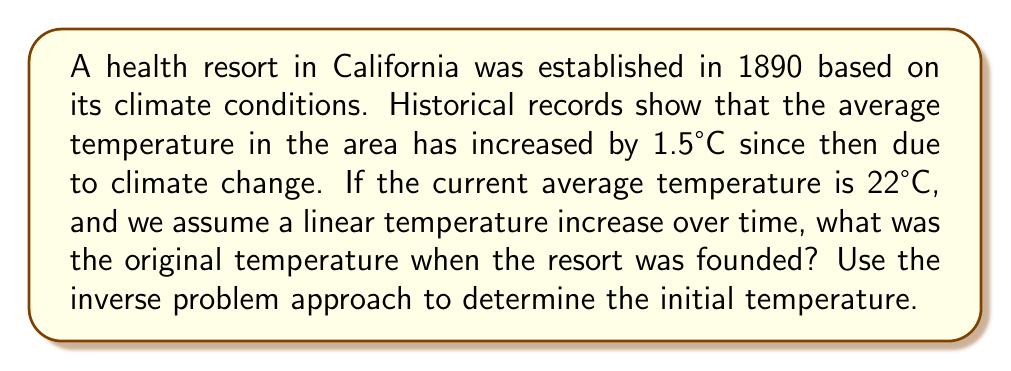Can you solve this math problem? To solve this inverse problem, we need to work backwards from the current known conditions to infer the original temperature. Let's approach this step-by-step:

1) Let $T_0$ be the original temperature we're trying to find.
2) Let $T_c$ be the current temperature, which is given as 22°C.
3) The temperature increase is 1.5°C over 133 years (from 1890 to 2023).
4) Assuming a linear increase, we can set up the equation:

   $T_c = T_0 + 1.5$

5) Substituting the known current temperature:

   $22 = T_0 + 1.5$

6) To solve for $T_0$, we subtract 1.5 from both sides:

   $T_0 = 22 - 1.5 = 20.5$

Therefore, the original temperature when the resort was founded was 20.5°C.

This inverse problem demonstrates how we can use current data and known changes over time to infer historical conditions, which is crucial in understanding the factors that influenced the establishment of health resorts in specific locations.
Answer: 20.5°C 